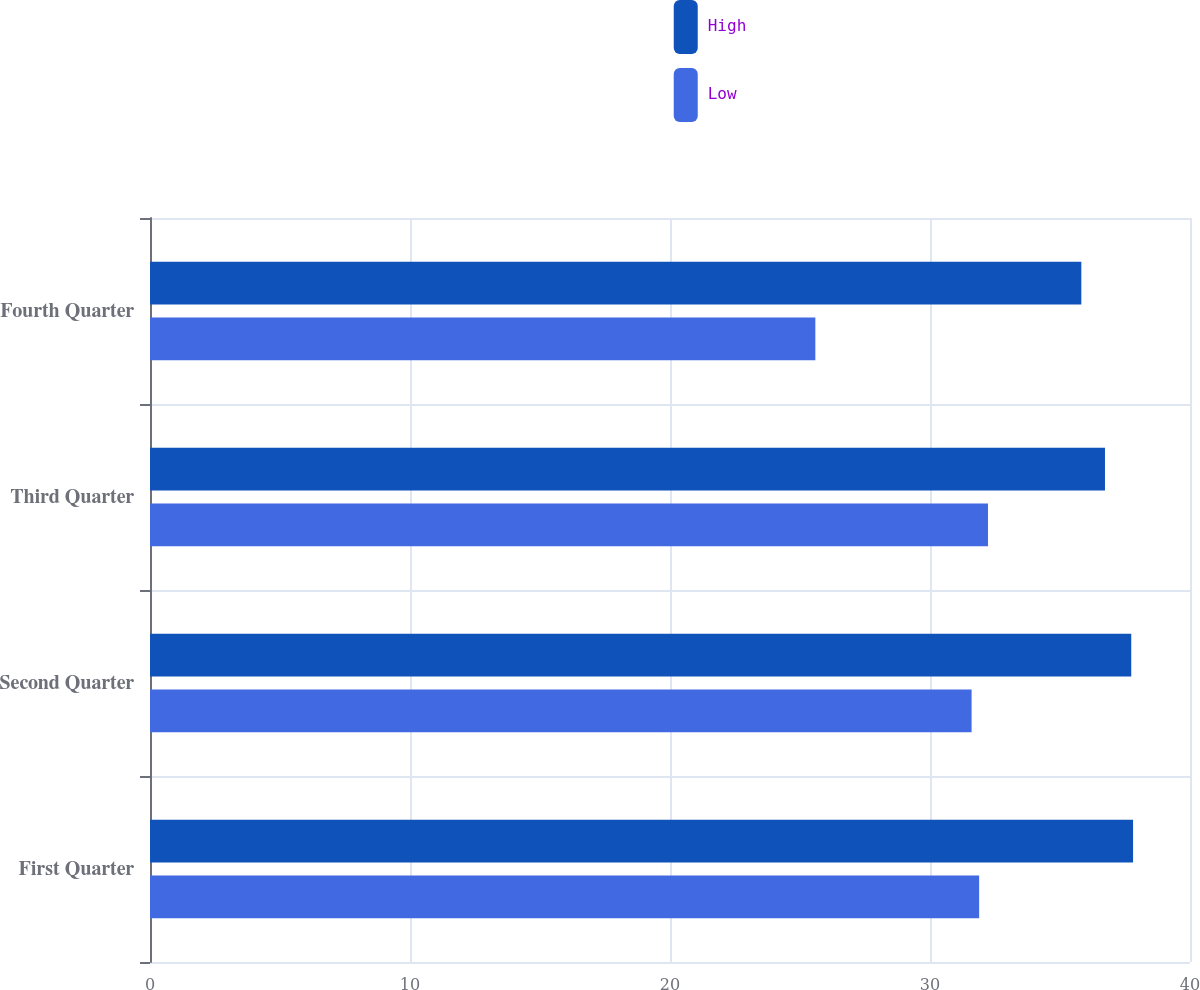Convert chart to OTSL. <chart><loc_0><loc_0><loc_500><loc_500><stacked_bar_chart><ecel><fcel>First Quarter<fcel>Second Quarter<fcel>Third Quarter<fcel>Fourth Quarter<nl><fcel>High<fcel>37.81<fcel>37.74<fcel>36.73<fcel>35.82<nl><fcel>Low<fcel>31.89<fcel>31.6<fcel>32.23<fcel>25.59<nl></chart> 